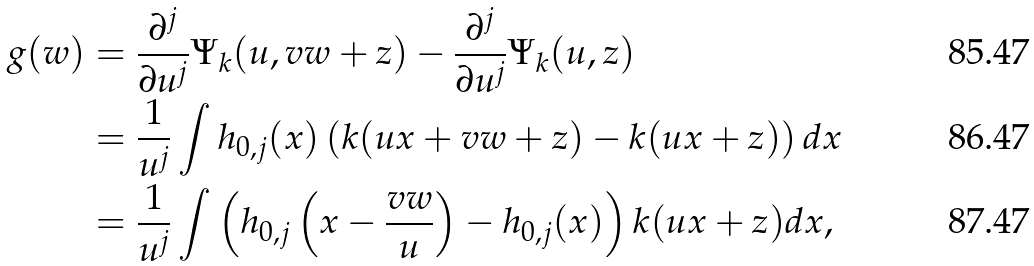<formula> <loc_0><loc_0><loc_500><loc_500>g ( w ) & = \frac { \partial ^ { j } } { \partial u ^ { j } } \Psi _ { k } ( u , v w + z ) - \frac { \partial ^ { j } } { \partial u ^ { j } } \Psi _ { k } ( u , z ) \\ & = \frac { 1 } { u ^ { j } } \int h _ { 0 , j } ( x ) \left ( k ( u x + v w + z ) - k ( u x + z ) \right ) d x \\ & = \frac { 1 } { u ^ { j } } \int \left ( h _ { 0 , j } \left ( x - \frac { v w } { u } \right ) - h _ { 0 , j } ( x ) \right ) k ( u x + z ) d x ,</formula> 